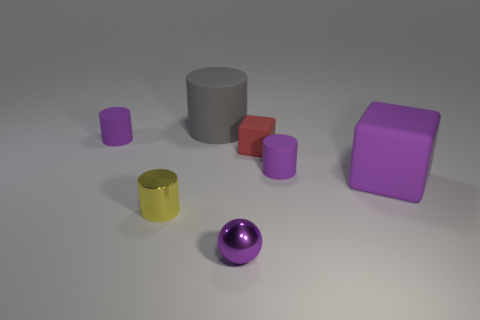Subtract all large gray cylinders. How many cylinders are left? 3 Subtract all cylinders. How many objects are left? 3 Add 3 big green blocks. How many objects exist? 10 Subtract all red cubes. How many cubes are left? 1 Subtract 0 green cubes. How many objects are left? 7 Subtract 1 balls. How many balls are left? 0 Subtract all red blocks. Subtract all brown cylinders. How many blocks are left? 1 Subtract all red cubes. How many brown cylinders are left? 0 Subtract all yellow matte spheres. Subtract all purple matte cylinders. How many objects are left? 5 Add 5 red matte blocks. How many red matte blocks are left? 6 